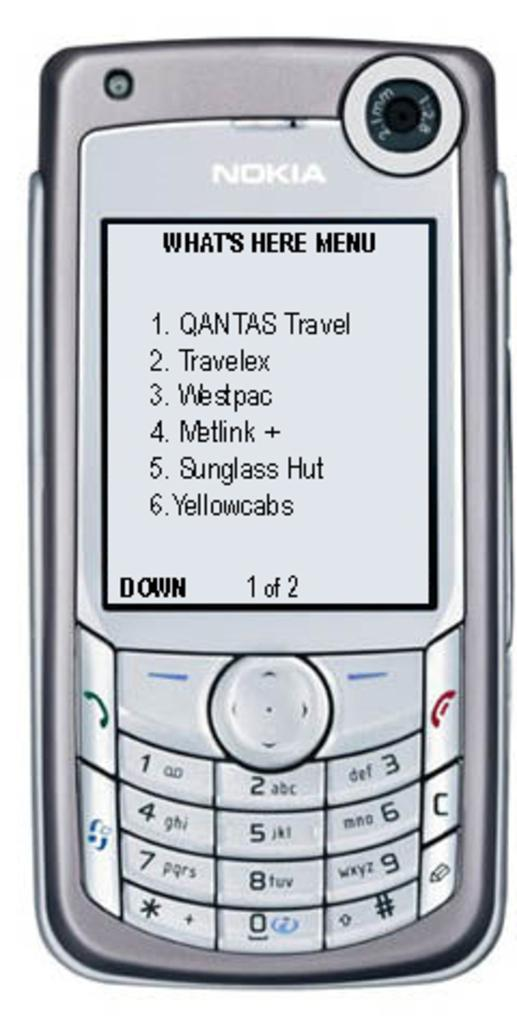<image>
Render a clear and concise summary of the photo. A Nokia phone displays a What's Here Menu, including QANTAS Travel and Travelex. 